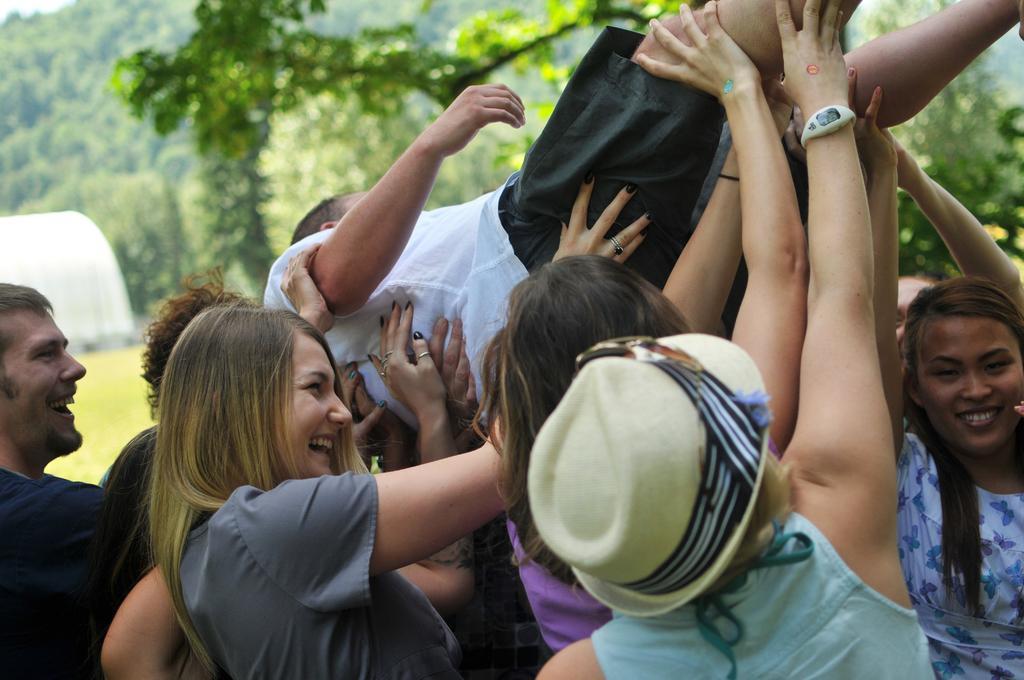Could you give a brief overview of what you see in this image? In this image there are many people. They are lifting a person. They all are smiling. In the background there are trees. Here this is a tent like structure. 